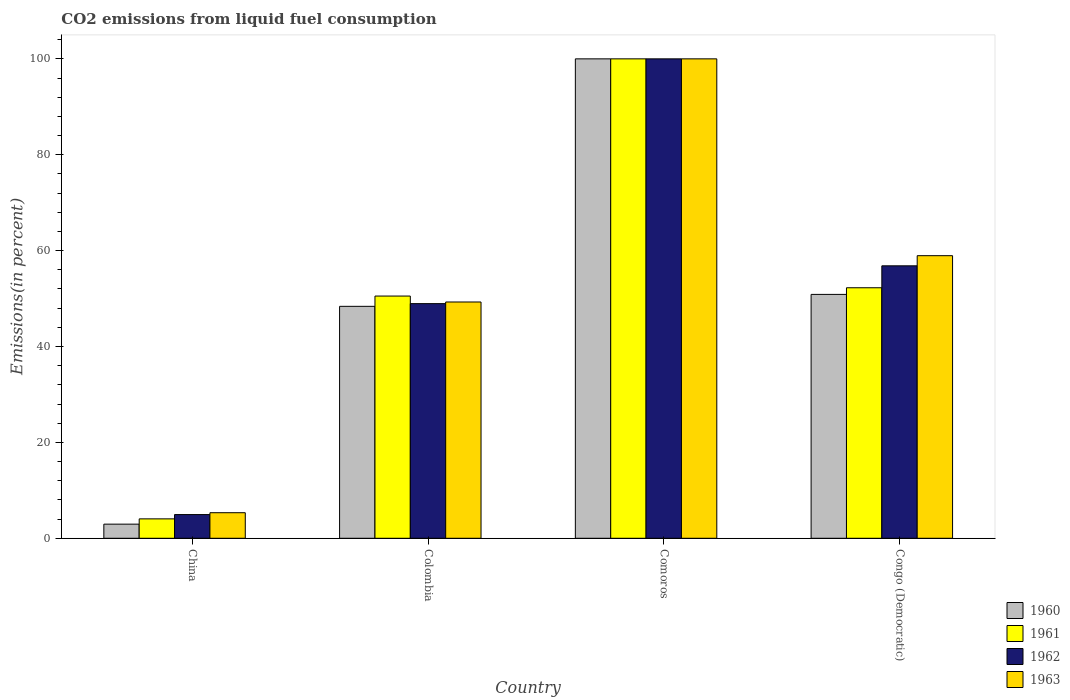How many groups of bars are there?
Offer a very short reply. 4. Are the number of bars on each tick of the X-axis equal?
Your answer should be very brief. Yes. How many bars are there on the 3rd tick from the right?
Provide a short and direct response. 4. What is the label of the 2nd group of bars from the left?
Offer a terse response. Colombia. In how many cases, is the number of bars for a given country not equal to the number of legend labels?
Offer a very short reply. 0. What is the total CO2 emitted in 1962 in Colombia?
Provide a short and direct response. 48.94. Across all countries, what is the maximum total CO2 emitted in 1961?
Your answer should be very brief. 100. Across all countries, what is the minimum total CO2 emitted in 1962?
Offer a very short reply. 4.95. In which country was the total CO2 emitted in 1960 maximum?
Your answer should be very brief. Comoros. What is the total total CO2 emitted in 1961 in the graph?
Make the answer very short. 206.83. What is the difference between the total CO2 emitted in 1963 in Comoros and that in Congo (Democratic)?
Your response must be concise. 41.05. What is the difference between the total CO2 emitted in 1963 in Congo (Democratic) and the total CO2 emitted in 1962 in Comoros?
Ensure brevity in your answer.  -41.05. What is the average total CO2 emitted in 1960 per country?
Make the answer very short. 50.55. What is the difference between the total CO2 emitted of/in 1960 and total CO2 emitted of/in 1963 in Congo (Democratic)?
Give a very brief answer. -8.08. What is the ratio of the total CO2 emitted in 1961 in Colombia to that in Comoros?
Offer a terse response. 0.51. Is the difference between the total CO2 emitted in 1960 in Colombia and Comoros greater than the difference between the total CO2 emitted in 1963 in Colombia and Comoros?
Your answer should be very brief. No. What is the difference between the highest and the second highest total CO2 emitted in 1960?
Provide a short and direct response. -2.49. What is the difference between the highest and the lowest total CO2 emitted in 1963?
Your answer should be compact. 94.67. Is the sum of the total CO2 emitted in 1961 in Colombia and Comoros greater than the maximum total CO2 emitted in 1962 across all countries?
Offer a terse response. Yes. What does the 4th bar from the left in China represents?
Keep it short and to the point. 1963. How many bars are there?
Keep it short and to the point. 16. Are all the bars in the graph horizontal?
Offer a terse response. No. How many countries are there in the graph?
Your answer should be very brief. 4. Does the graph contain any zero values?
Your answer should be very brief. No. Does the graph contain grids?
Keep it short and to the point. No. Where does the legend appear in the graph?
Your answer should be compact. Bottom right. How many legend labels are there?
Make the answer very short. 4. What is the title of the graph?
Your response must be concise. CO2 emissions from liquid fuel consumption. What is the label or title of the X-axis?
Make the answer very short. Country. What is the label or title of the Y-axis?
Your response must be concise. Emissions(in percent). What is the Emissions(in percent) in 1960 in China?
Offer a very short reply. 2.95. What is the Emissions(in percent) of 1961 in China?
Your answer should be very brief. 4.05. What is the Emissions(in percent) of 1962 in China?
Ensure brevity in your answer.  4.95. What is the Emissions(in percent) in 1963 in China?
Your answer should be very brief. 5.33. What is the Emissions(in percent) of 1960 in Colombia?
Your response must be concise. 48.38. What is the Emissions(in percent) of 1961 in Colombia?
Make the answer very short. 50.52. What is the Emissions(in percent) of 1962 in Colombia?
Provide a short and direct response. 48.94. What is the Emissions(in percent) of 1963 in Colombia?
Offer a very short reply. 49.28. What is the Emissions(in percent) of 1961 in Comoros?
Offer a very short reply. 100. What is the Emissions(in percent) in 1962 in Comoros?
Make the answer very short. 100. What is the Emissions(in percent) of 1963 in Comoros?
Provide a short and direct response. 100. What is the Emissions(in percent) of 1960 in Congo (Democratic)?
Offer a very short reply. 50.87. What is the Emissions(in percent) in 1961 in Congo (Democratic)?
Give a very brief answer. 52.26. What is the Emissions(in percent) of 1962 in Congo (Democratic)?
Offer a very short reply. 56.83. What is the Emissions(in percent) in 1963 in Congo (Democratic)?
Your response must be concise. 58.95. Across all countries, what is the maximum Emissions(in percent) of 1960?
Your answer should be compact. 100. Across all countries, what is the maximum Emissions(in percent) of 1961?
Make the answer very short. 100. Across all countries, what is the maximum Emissions(in percent) of 1962?
Offer a terse response. 100. Across all countries, what is the minimum Emissions(in percent) in 1960?
Offer a very short reply. 2.95. Across all countries, what is the minimum Emissions(in percent) of 1961?
Make the answer very short. 4.05. Across all countries, what is the minimum Emissions(in percent) of 1962?
Make the answer very short. 4.95. Across all countries, what is the minimum Emissions(in percent) in 1963?
Provide a short and direct response. 5.33. What is the total Emissions(in percent) in 1960 in the graph?
Ensure brevity in your answer.  202.2. What is the total Emissions(in percent) in 1961 in the graph?
Make the answer very short. 206.83. What is the total Emissions(in percent) of 1962 in the graph?
Keep it short and to the point. 210.72. What is the total Emissions(in percent) of 1963 in the graph?
Offer a terse response. 213.56. What is the difference between the Emissions(in percent) in 1960 in China and that in Colombia?
Offer a very short reply. -45.43. What is the difference between the Emissions(in percent) in 1961 in China and that in Colombia?
Give a very brief answer. -46.47. What is the difference between the Emissions(in percent) of 1962 in China and that in Colombia?
Provide a short and direct response. -44. What is the difference between the Emissions(in percent) in 1963 in China and that in Colombia?
Offer a very short reply. -43.95. What is the difference between the Emissions(in percent) in 1960 in China and that in Comoros?
Offer a terse response. -97.05. What is the difference between the Emissions(in percent) in 1961 in China and that in Comoros?
Provide a succinct answer. -95.95. What is the difference between the Emissions(in percent) of 1962 in China and that in Comoros?
Your answer should be very brief. -95.05. What is the difference between the Emissions(in percent) in 1963 in China and that in Comoros?
Offer a terse response. -94.67. What is the difference between the Emissions(in percent) of 1960 in China and that in Congo (Democratic)?
Keep it short and to the point. -47.92. What is the difference between the Emissions(in percent) of 1961 in China and that in Congo (Democratic)?
Your answer should be compact. -48.21. What is the difference between the Emissions(in percent) of 1962 in China and that in Congo (Democratic)?
Your answer should be compact. -51.88. What is the difference between the Emissions(in percent) in 1963 in China and that in Congo (Democratic)?
Offer a terse response. -53.61. What is the difference between the Emissions(in percent) of 1960 in Colombia and that in Comoros?
Your response must be concise. -51.62. What is the difference between the Emissions(in percent) of 1961 in Colombia and that in Comoros?
Offer a very short reply. -49.48. What is the difference between the Emissions(in percent) in 1962 in Colombia and that in Comoros?
Provide a short and direct response. -51.06. What is the difference between the Emissions(in percent) of 1963 in Colombia and that in Comoros?
Your answer should be very brief. -50.72. What is the difference between the Emissions(in percent) in 1960 in Colombia and that in Congo (Democratic)?
Offer a terse response. -2.49. What is the difference between the Emissions(in percent) in 1961 in Colombia and that in Congo (Democratic)?
Give a very brief answer. -1.73. What is the difference between the Emissions(in percent) of 1962 in Colombia and that in Congo (Democratic)?
Make the answer very short. -7.89. What is the difference between the Emissions(in percent) in 1963 in Colombia and that in Congo (Democratic)?
Keep it short and to the point. -9.66. What is the difference between the Emissions(in percent) in 1960 in Comoros and that in Congo (Democratic)?
Keep it short and to the point. 49.13. What is the difference between the Emissions(in percent) of 1961 in Comoros and that in Congo (Democratic)?
Your response must be concise. 47.74. What is the difference between the Emissions(in percent) of 1962 in Comoros and that in Congo (Democratic)?
Provide a short and direct response. 43.17. What is the difference between the Emissions(in percent) of 1963 in Comoros and that in Congo (Democratic)?
Ensure brevity in your answer.  41.05. What is the difference between the Emissions(in percent) of 1960 in China and the Emissions(in percent) of 1961 in Colombia?
Your answer should be compact. -47.58. What is the difference between the Emissions(in percent) in 1960 in China and the Emissions(in percent) in 1962 in Colombia?
Ensure brevity in your answer.  -46. What is the difference between the Emissions(in percent) of 1960 in China and the Emissions(in percent) of 1963 in Colombia?
Your answer should be compact. -46.34. What is the difference between the Emissions(in percent) in 1961 in China and the Emissions(in percent) in 1962 in Colombia?
Your answer should be compact. -44.89. What is the difference between the Emissions(in percent) in 1961 in China and the Emissions(in percent) in 1963 in Colombia?
Offer a terse response. -45.23. What is the difference between the Emissions(in percent) in 1962 in China and the Emissions(in percent) in 1963 in Colombia?
Make the answer very short. -44.34. What is the difference between the Emissions(in percent) of 1960 in China and the Emissions(in percent) of 1961 in Comoros?
Offer a very short reply. -97.05. What is the difference between the Emissions(in percent) of 1960 in China and the Emissions(in percent) of 1962 in Comoros?
Provide a succinct answer. -97.05. What is the difference between the Emissions(in percent) of 1960 in China and the Emissions(in percent) of 1963 in Comoros?
Your answer should be compact. -97.05. What is the difference between the Emissions(in percent) in 1961 in China and the Emissions(in percent) in 1962 in Comoros?
Offer a very short reply. -95.95. What is the difference between the Emissions(in percent) of 1961 in China and the Emissions(in percent) of 1963 in Comoros?
Provide a short and direct response. -95.95. What is the difference between the Emissions(in percent) of 1962 in China and the Emissions(in percent) of 1963 in Comoros?
Ensure brevity in your answer.  -95.05. What is the difference between the Emissions(in percent) in 1960 in China and the Emissions(in percent) in 1961 in Congo (Democratic)?
Offer a terse response. -49.31. What is the difference between the Emissions(in percent) in 1960 in China and the Emissions(in percent) in 1962 in Congo (Democratic)?
Make the answer very short. -53.88. What is the difference between the Emissions(in percent) in 1960 in China and the Emissions(in percent) in 1963 in Congo (Democratic)?
Make the answer very short. -56. What is the difference between the Emissions(in percent) of 1961 in China and the Emissions(in percent) of 1962 in Congo (Democratic)?
Keep it short and to the point. -52.78. What is the difference between the Emissions(in percent) of 1961 in China and the Emissions(in percent) of 1963 in Congo (Democratic)?
Provide a short and direct response. -54.9. What is the difference between the Emissions(in percent) in 1962 in China and the Emissions(in percent) in 1963 in Congo (Democratic)?
Your answer should be very brief. -54. What is the difference between the Emissions(in percent) of 1960 in Colombia and the Emissions(in percent) of 1961 in Comoros?
Offer a terse response. -51.62. What is the difference between the Emissions(in percent) in 1960 in Colombia and the Emissions(in percent) in 1962 in Comoros?
Provide a succinct answer. -51.62. What is the difference between the Emissions(in percent) in 1960 in Colombia and the Emissions(in percent) in 1963 in Comoros?
Provide a succinct answer. -51.62. What is the difference between the Emissions(in percent) of 1961 in Colombia and the Emissions(in percent) of 1962 in Comoros?
Ensure brevity in your answer.  -49.48. What is the difference between the Emissions(in percent) of 1961 in Colombia and the Emissions(in percent) of 1963 in Comoros?
Keep it short and to the point. -49.48. What is the difference between the Emissions(in percent) in 1962 in Colombia and the Emissions(in percent) in 1963 in Comoros?
Your answer should be very brief. -51.06. What is the difference between the Emissions(in percent) in 1960 in Colombia and the Emissions(in percent) in 1961 in Congo (Democratic)?
Provide a short and direct response. -3.88. What is the difference between the Emissions(in percent) in 1960 in Colombia and the Emissions(in percent) in 1962 in Congo (Democratic)?
Your answer should be compact. -8.45. What is the difference between the Emissions(in percent) of 1960 in Colombia and the Emissions(in percent) of 1963 in Congo (Democratic)?
Make the answer very short. -10.57. What is the difference between the Emissions(in percent) of 1961 in Colombia and the Emissions(in percent) of 1962 in Congo (Democratic)?
Provide a succinct answer. -6.31. What is the difference between the Emissions(in percent) of 1961 in Colombia and the Emissions(in percent) of 1963 in Congo (Democratic)?
Your answer should be compact. -8.42. What is the difference between the Emissions(in percent) of 1962 in Colombia and the Emissions(in percent) of 1963 in Congo (Democratic)?
Ensure brevity in your answer.  -10. What is the difference between the Emissions(in percent) in 1960 in Comoros and the Emissions(in percent) in 1961 in Congo (Democratic)?
Provide a succinct answer. 47.74. What is the difference between the Emissions(in percent) in 1960 in Comoros and the Emissions(in percent) in 1962 in Congo (Democratic)?
Your answer should be compact. 43.17. What is the difference between the Emissions(in percent) of 1960 in Comoros and the Emissions(in percent) of 1963 in Congo (Democratic)?
Give a very brief answer. 41.05. What is the difference between the Emissions(in percent) in 1961 in Comoros and the Emissions(in percent) in 1962 in Congo (Democratic)?
Make the answer very short. 43.17. What is the difference between the Emissions(in percent) in 1961 in Comoros and the Emissions(in percent) in 1963 in Congo (Democratic)?
Your answer should be compact. 41.05. What is the difference between the Emissions(in percent) of 1962 in Comoros and the Emissions(in percent) of 1963 in Congo (Democratic)?
Your response must be concise. 41.05. What is the average Emissions(in percent) in 1960 per country?
Ensure brevity in your answer.  50.55. What is the average Emissions(in percent) of 1961 per country?
Provide a short and direct response. 51.71. What is the average Emissions(in percent) in 1962 per country?
Make the answer very short. 52.68. What is the average Emissions(in percent) of 1963 per country?
Provide a short and direct response. 53.39. What is the difference between the Emissions(in percent) of 1960 and Emissions(in percent) of 1961 in China?
Provide a succinct answer. -1.1. What is the difference between the Emissions(in percent) of 1960 and Emissions(in percent) of 1962 in China?
Make the answer very short. -2. What is the difference between the Emissions(in percent) of 1960 and Emissions(in percent) of 1963 in China?
Give a very brief answer. -2.39. What is the difference between the Emissions(in percent) in 1961 and Emissions(in percent) in 1962 in China?
Offer a very short reply. -0.9. What is the difference between the Emissions(in percent) of 1961 and Emissions(in percent) of 1963 in China?
Offer a terse response. -1.28. What is the difference between the Emissions(in percent) of 1962 and Emissions(in percent) of 1963 in China?
Provide a succinct answer. -0.39. What is the difference between the Emissions(in percent) of 1960 and Emissions(in percent) of 1961 in Colombia?
Your response must be concise. -2.14. What is the difference between the Emissions(in percent) of 1960 and Emissions(in percent) of 1962 in Colombia?
Provide a short and direct response. -0.56. What is the difference between the Emissions(in percent) in 1960 and Emissions(in percent) in 1963 in Colombia?
Your answer should be very brief. -0.9. What is the difference between the Emissions(in percent) of 1961 and Emissions(in percent) of 1962 in Colombia?
Ensure brevity in your answer.  1.58. What is the difference between the Emissions(in percent) of 1961 and Emissions(in percent) of 1963 in Colombia?
Ensure brevity in your answer.  1.24. What is the difference between the Emissions(in percent) of 1962 and Emissions(in percent) of 1963 in Colombia?
Provide a succinct answer. -0.34. What is the difference between the Emissions(in percent) in 1961 and Emissions(in percent) in 1963 in Comoros?
Provide a short and direct response. 0. What is the difference between the Emissions(in percent) of 1962 and Emissions(in percent) of 1963 in Comoros?
Your response must be concise. 0. What is the difference between the Emissions(in percent) in 1960 and Emissions(in percent) in 1961 in Congo (Democratic)?
Ensure brevity in your answer.  -1.39. What is the difference between the Emissions(in percent) of 1960 and Emissions(in percent) of 1962 in Congo (Democratic)?
Offer a terse response. -5.96. What is the difference between the Emissions(in percent) in 1960 and Emissions(in percent) in 1963 in Congo (Democratic)?
Make the answer very short. -8.08. What is the difference between the Emissions(in percent) in 1961 and Emissions(in percent) in 1962 in Congo (Democratic)?
Your answer should be very brief. -4.57. What is the difference between the Emissions(in percent) in 1961 and Emissions(in percent) in 1963 in Congo (Democratic)?
Your response must be concise. -6.69. What is the difference between the Emissions(in percent) in 1962 and Emissions(in percent) in 1963 in Congo (Democratic)?
Ensure brevity in your answer.  -2.12. What is the ratio of the Emissions(in percent) in 1960 in China to that in Colombia?
Make the answer very short. 0.06. What is the ratio of the Emissions(in percent) in 1961 in China to that in Colombia?
Ensure brevity in your answer.  0.08. What is the ratio of the Emissions(in percent) in 1962 in China to that in Colombia?
Ensure brevity in your answer.  0.1. What is the ratio of the Emissions(in percent) in 1963 in China to that in Colombia?
Make the answer very short. 0.11. What is the ratio of the Emissions(in percent) in 1960 in China to that in Comoros?
Your answer should be compact. 0.03. What is the ratio of the Emissions(in percent) of 1961 in China to that in Comoros?
Provide a succinct answer. 0.04. What is the ratio of the Emissions(in percent) in 1962 in China to that in Comoros?
Your response must be concise. 0.05. What is the ratio of the Emissions(in percent) in 1963 in China to that in Comoros?
Provide a short and direct response. 0.05. What is the ratio of the Emissions(in percent) in 1960 in China to that in Congo (Democratic)?
Keep it short and to the point. 0.06. What is the ratio of the Emissions(in percent) of 1961 in China to that in Congo (Democratic)?
Your response must be concise. 0.08. What is the ratio of the Emissions(in percent) of 1962 in China to that in Congo (Democratic)?
Provide a short and direct response. 0.09. What is the ratio of the Emissions(in percent) of 1963 in China to that in Congo (Democratic)?
Make the answer very short. 0.09. What is the ratio of the Emissions(in percent) of 1960 in Colombia to that in Comoros?
Provide a short and direct response. 0.48. What is the ratio of the Emissions(in percent) in 1961 in Colombia to that in Comoros?
Your answer should be very brief. 0.51. What is the ratio of the Emissions(in percent) in 1962 in Colombia to that in Comoros?
Give a very brief answer. 0.49. What is the ratio of the Emissions(in percent) of 1963 in Colombia to that in Comoros?
Provide a short and direct response. 0.49. What is the ratio of the Emissions(in percent) of 1960 in Colombia to that in Congo (Democratic)?
Your answer should be very brief. 0.95. What is the ratio of the Emissions(in percent) in 1961 in Colombia to that in Congo (Democratic)?
Keep it short and to the point. 0.97. What is the ratio of the Emissions(in percent) of 1962 in Colombia to that in Congo (Democratic)?
Offer a terse response. 0.86. What is the ratio of the Emissions(in percent) of 1963 in Colombia to that in Congo (Democratic)?
Your answer should be very brief. 0.84. What is the ratio of the Emissions(in percent) in 1960 in Comoros to that in Congo (Democratic)?
Provide a succinct answer. 1.97. What is the ratio of the Emissions(in percent) of 1961 in Comoros to that in Congo (Democratic)?
Provide a succinct answer. 1.91. What is the ratio of the Emissions(in percent) of 1962 in Comoros to that in Congo (Democratic)?
Your answer should be very brief. 1.76. What is the ratio of the Emissions(in percent) in 1963 in Comoros to that in Congo (Democratic)?
Ensure brevity in your answer.  1.7. What is the difference between the highest and the second highest Emissions(in percent) of 1960?
Provide a short and direct response. 49.13. What is the difference between the highest and the second highest Emissions(in percent) in 1961?
Your response must be concise. 47.74. What is the difference between the highest and the second highest Emissions(in percent) of 1962?
Offer a terse response. 43.17. What is the difference between the highest and the second highest Emissions(in percent) in 1963?
Ensure brevity in your answer.  41.05. What is the difference between the highest and the lowest Emissions(in percent) in 1960?
Make the answer very short. 97.05. What is the difference between the highest and the lowest Emissions(in percent) of 1961?
Offer a terse response. 95.95. What is the difference between the highest and the lowest Emissions(in percent) of 1962?
Make the answer very short. 95.05. What is the difference between the highest and the lowest Emissions(in percent) of 1963?
Your answer should be compact. 94.67. 